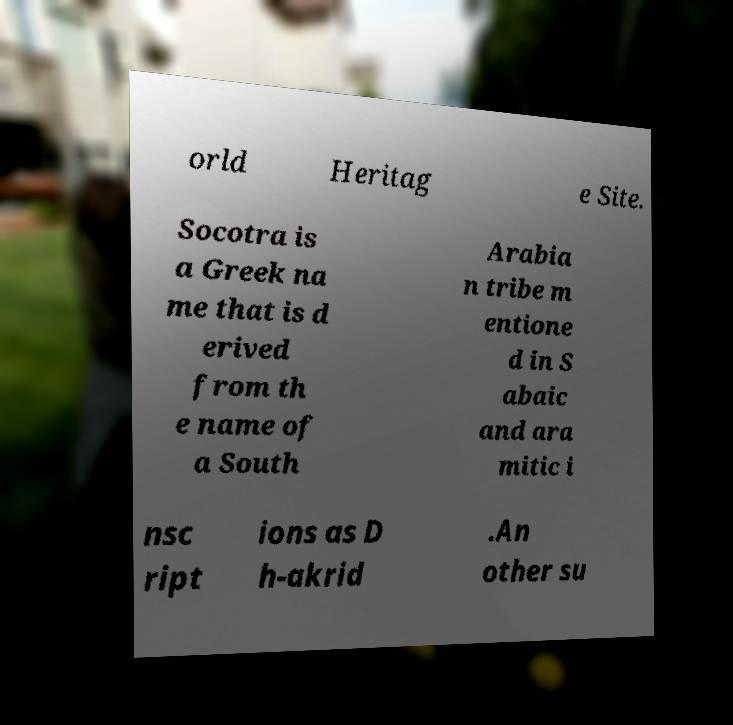Could you extract and type out the text from this image? orld Heritag e Site. Socotra is a Greek na me that is d erived from th e name of a South Arabia n tribe m entione d in S abaic and ara mitic i nsc ript ions as D h-akrid .An other su 